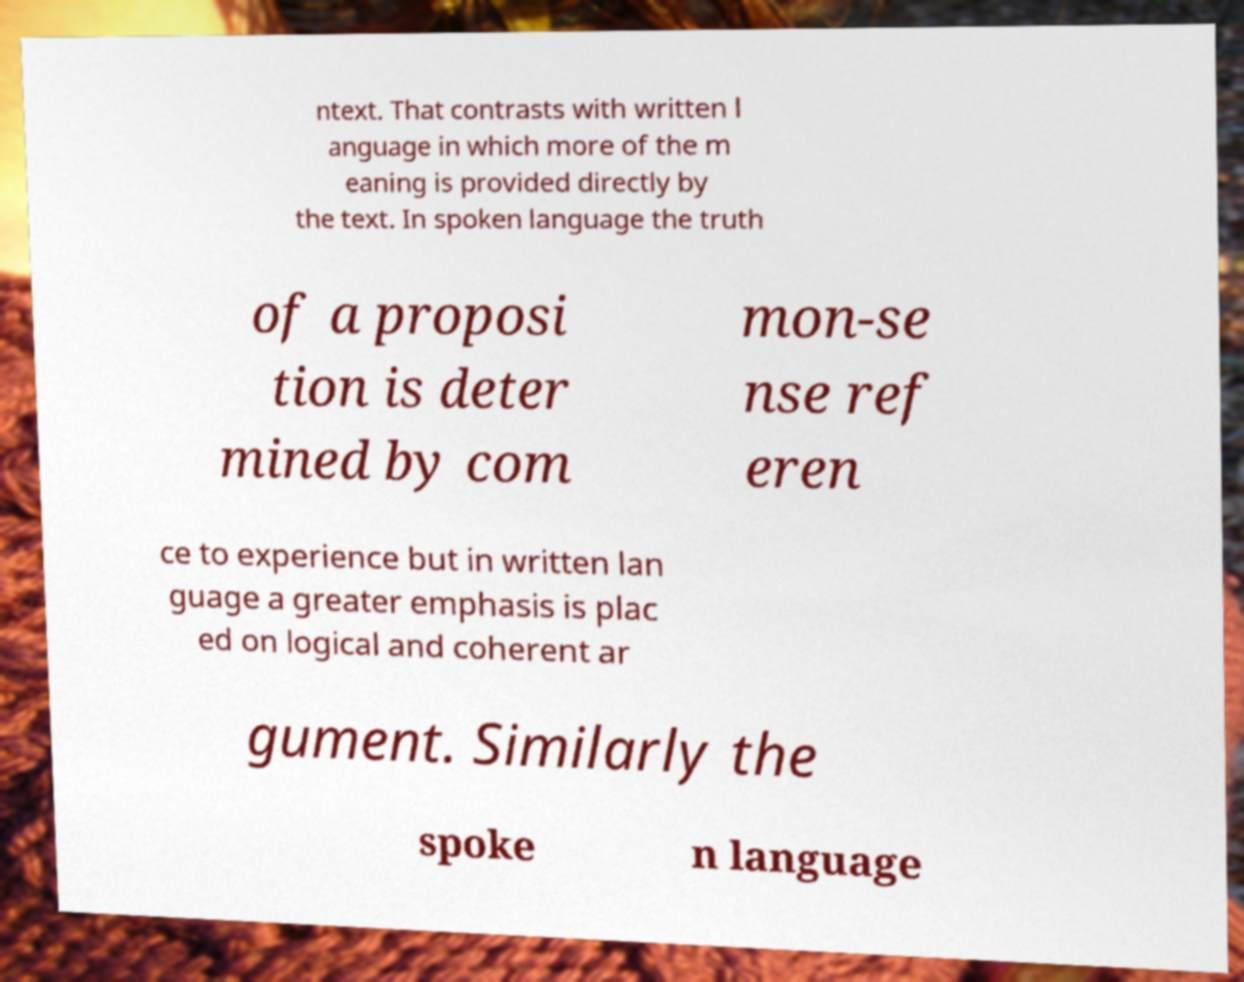There's text embedded in this image that I need extracted. Can you transcribe it verbatim? ntext. That contrasts with written l anguage in which more of the m eaning is provided directly by the text. In spoken language the truth of a proposi tion is deter mined by com mon-se nse ref eren ce to experience but in written lan guage a greater emphasis is plac ed on logical and coherent ar gument. Similarly the spoke n language 